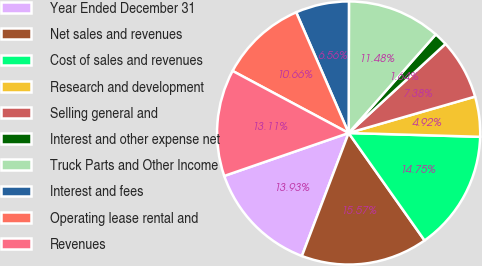Convert chart to OTSL. <chart><loc_0><loc_0><loc_500><loc_500><pie_chart><fcel>Year Ended December 31<fcel>Net sales and revenues<fcel>Cost of sales and revenues<fcel>Research and development<fcel>Selling general and<fcel>Interest and other expense net<fcel>Truck Parts and Other Income<fcel>Interest and fees<fcel>Operating lease rental and<fcel>Revenues<nl><fcel>13.93%<fcel>15.57%<fcel>14.75%<fcel>4.92%<fcel>7.38%<fcel>1.64%<fcel>11.48%<fcel>6.56%<fcel>10.66%<fcel>13.11%<nl></chart> 